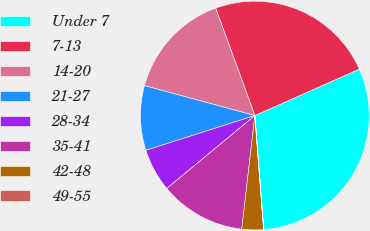<chart> <loc_0><loc_0><loc_500><loc_500><pie_chart><fcel>Under 7<fcel>7-13<fcel>14-20<fcel>21-27<fcel>28-34<fcel>35-41<fcel>42-48<fcel>49-55<nl><fcel>30.43%<fcel>23.91%<fcel>15.22%<fcel>9.13%<fcel>6.09%<fcel>12.17%<fcel>3.05%<fcel>0.01%<nl></chart> 